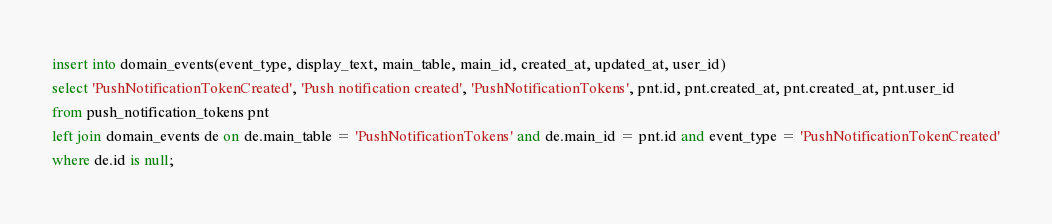<code> <loc_0><loc_0><loc_500><loc_500><_SQL_>insert into domain_events(event_type, display_text, main_table, main_id, created_at, updated_at, user_id)
select 'PushNotificationTokenCreated', 'Push notification created', 'PushNotificationTokens', pnt.id, pnt.created_at, pnt.created_at, pnt.user_id
from push_notification_tokens pnt
left join domain_events de on de.main_table = 'PushNotificationTokens' and de.main_id = pnt.id and event_type = 'PushNotificationTokenCreated'
where de.id is null;
</code> 